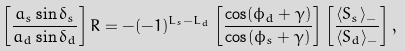<formula> <loc_0><loc_0><loc_500><loc_500>\left [ \frac { a _ { s } \sin \delta _ { s } } { a _ { d } \sin \delta _ { d } } \right ] R = - ( - 1 ) ^ { L _ { s } - L _ { d } } \left [ \frac { \cos ( \phi _ { d } + \gamma ) } { \cos ( \phi _ { s } + \gamma ) } \right ] \left [ \frac { \langle S _ { s } \rangle _ { - } } { \langle S _ { d } \rangle _ { - } } \right ] ,</formula> 